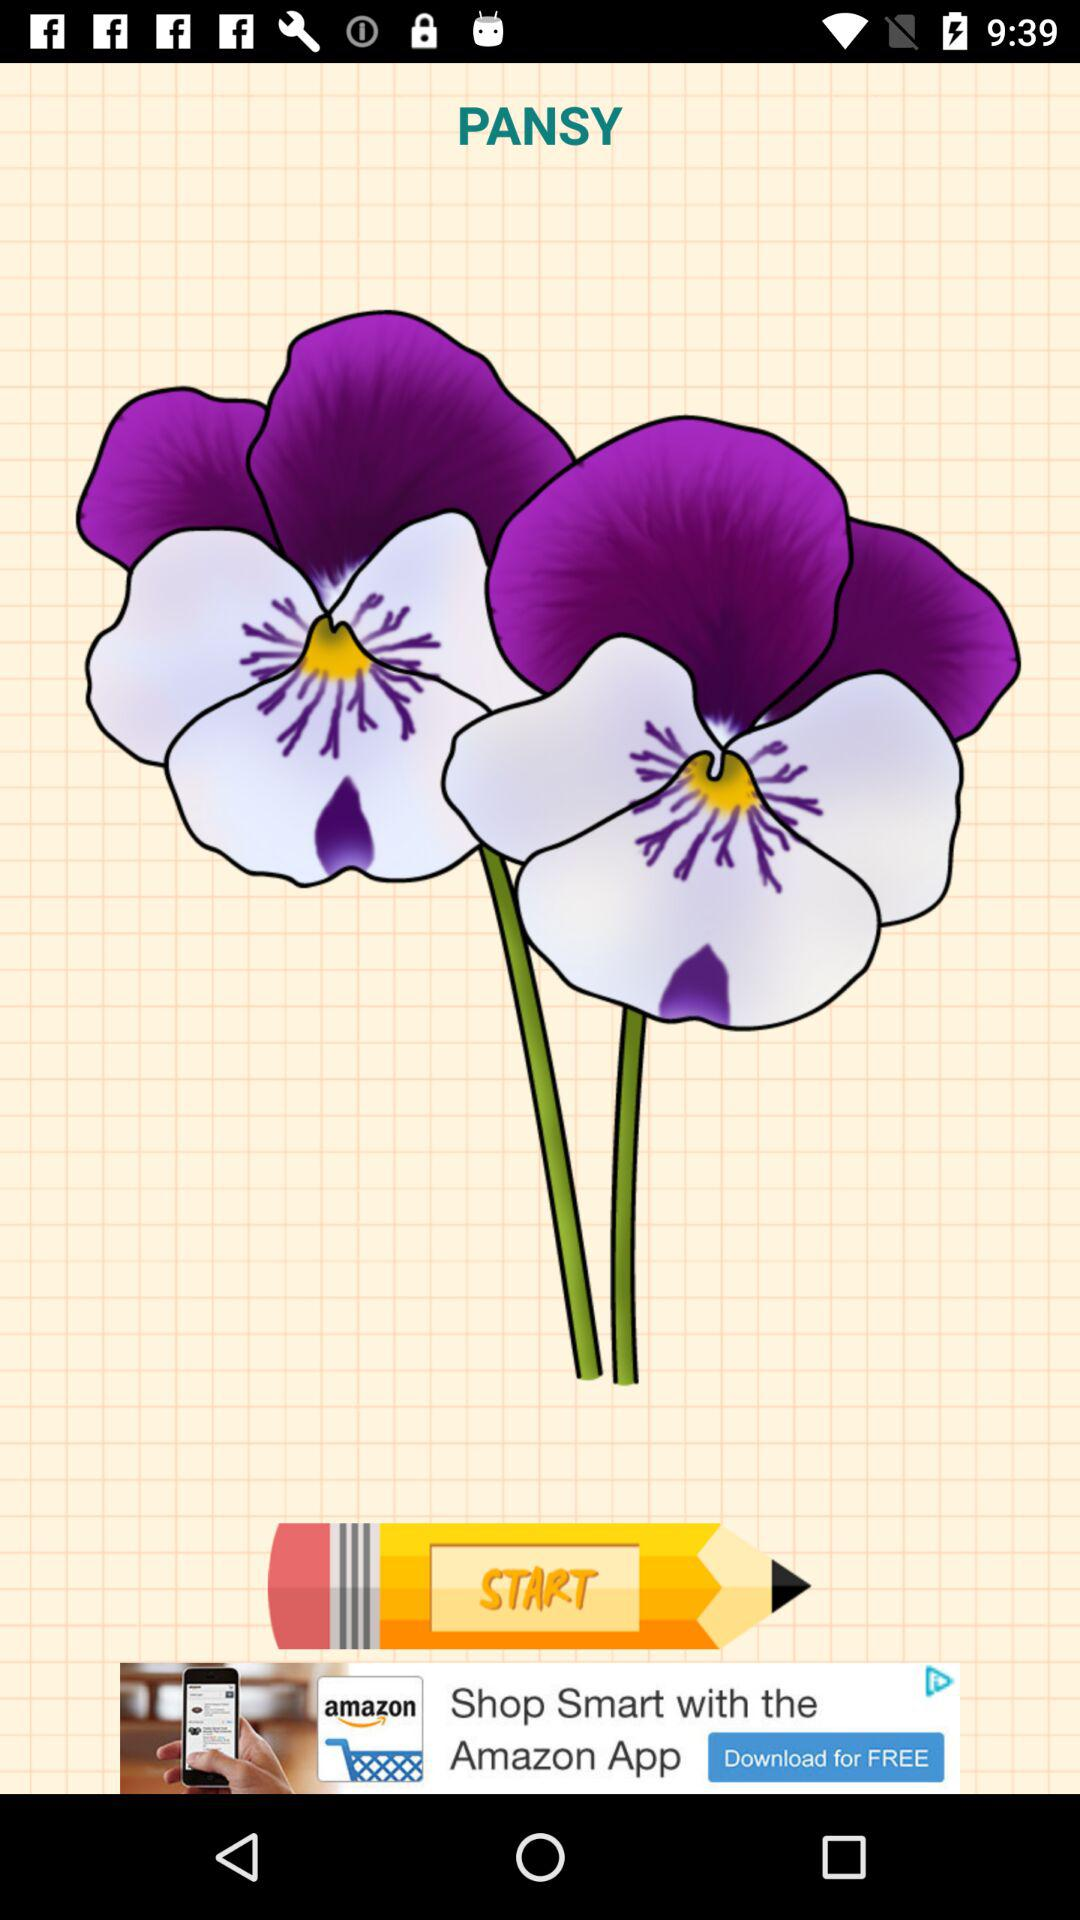What is the title of the image? The title of the image is "PANSY". 